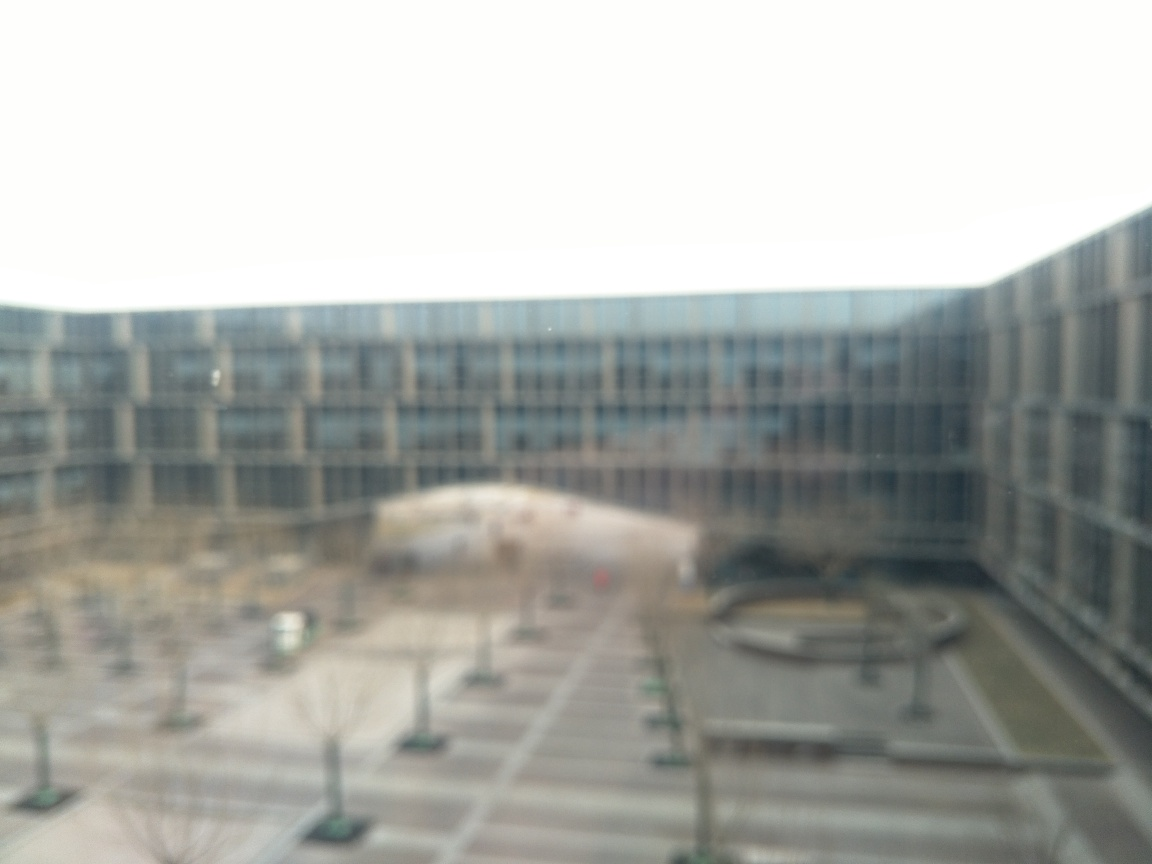What might be the reason for the image's low sharpness? The low sharpness in the image can be attributed to several possible factors. It could be the result of a technical issue, like an out-of-focus lens, camera motion or a long exposure without proper stabilization. Alternatively, this could be an intentional artistic choice by the photographer to create a dreamy or surreal effect. Lastly, environmental conditions such as mist, fog, or a smudged lens could also result in such an outcome. 